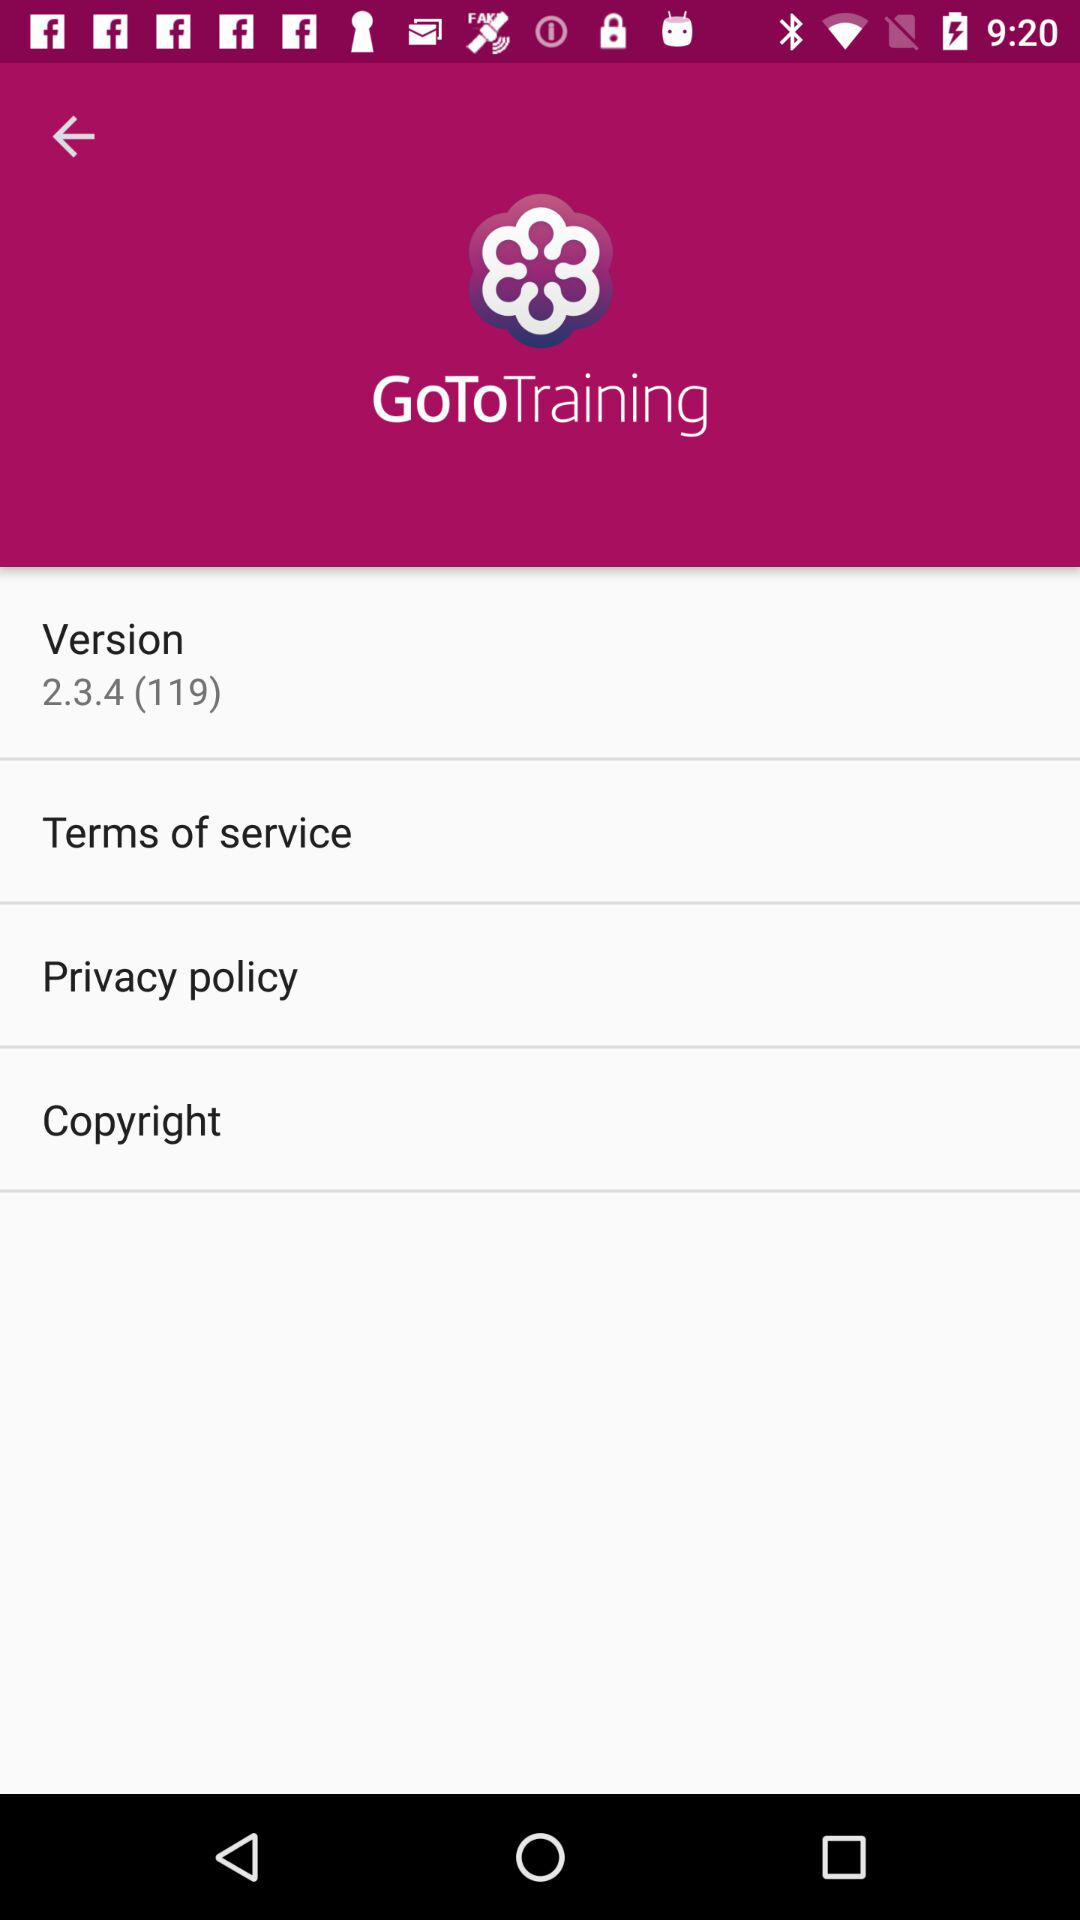What is the application name? The application name is "GoToTraining". 